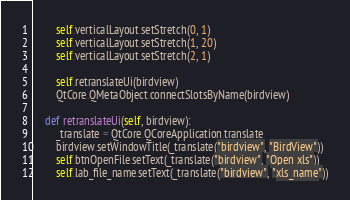Convert code to text. <code><loc_0><loc_0><loc_500><loc_500><_Python_>        self.verticalLayout.setStretch(0, 1)
        self.verticalLayout.setStretch(1, 20)
        self.verticalLayout.setStretch(2, 1)

        self.retranslateUi(birdview)
        QtCore.QMetaObject.connectSlotsByName(birdview)

    def retranslateUi(self, birdview):
        _translate = QtCore.QCoreApplication.translate
        birdview.setWindowTitle(_translate("birdview", "BirdView"))
        self.btnOpenFile.setText(_translate("birdview", "Open xls"))
        self.lab_file_name.setText(_translate("birdview", "xls_name"))
</code> 